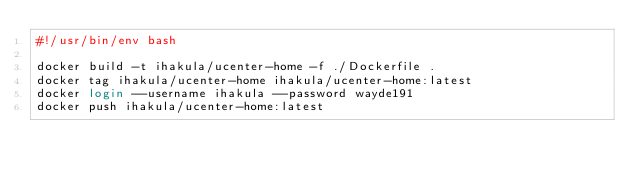Convert code to text. <code><loc_0><loc_0><loc_500><loc_500><_Bash_>#!/usr/bin/env bash

docker build -t ihakula/ucenter-home -f ./Dockerfile .
docker tag ihakula/ucenter-home ihakula/ucenter-home:latest
docker login --username ihakula --password wayde191
docker push ihakula/ucenter-home:latest
</code> 